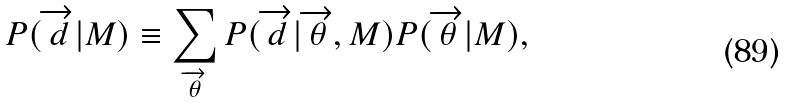Convert formula to latex. <formula><loc_0><loc_0><loc_500><loc_500>P ( \overrightarrow { d } | M ) \equiv \sum _ { \overrightarrow { \theta } } P ( \overrightarrow { d } | \overrightarrow { \theta } , M ) P ( \overrightarrow { \theta } | M ) ,</formula> 